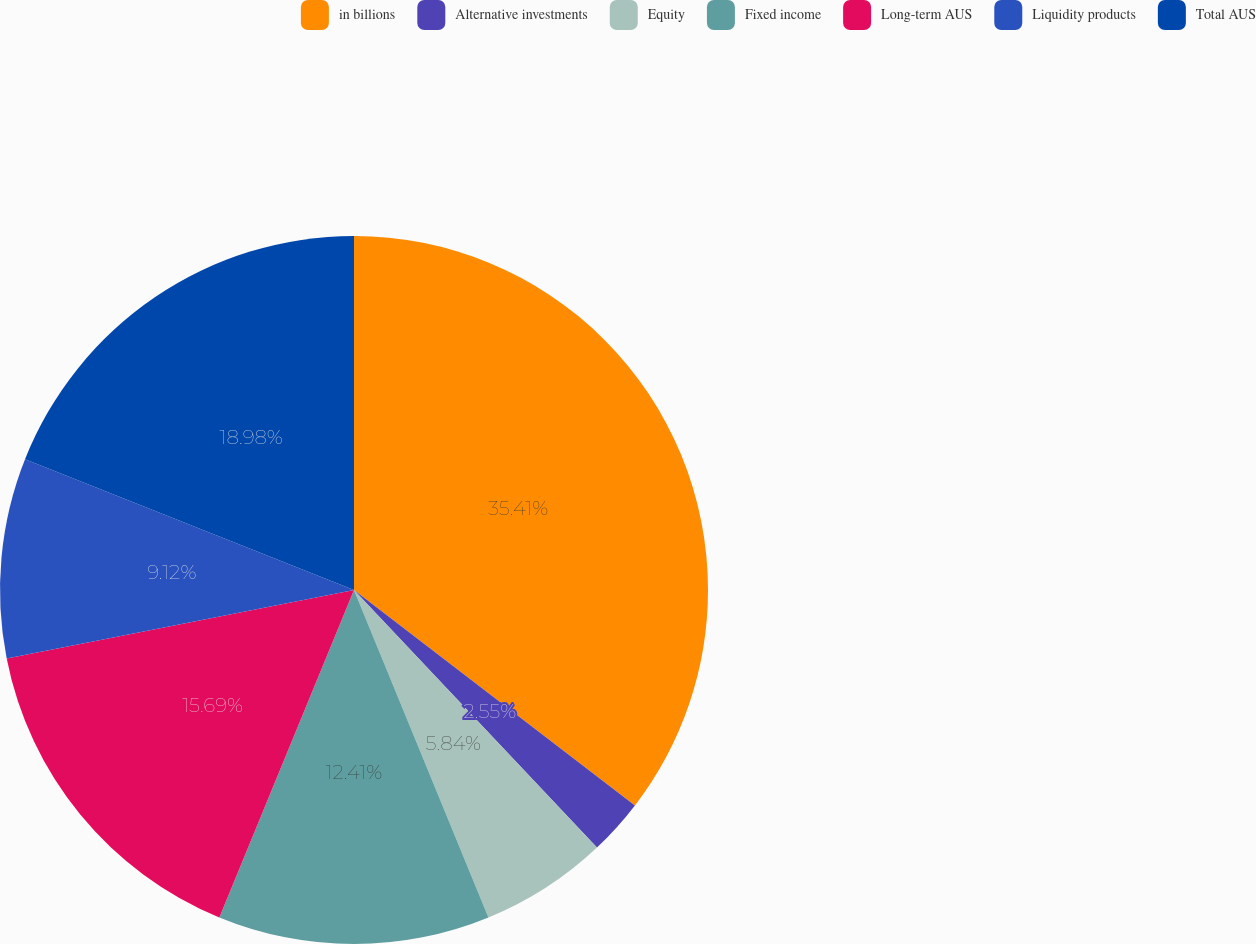<chart> <loc_0><loc_0><loc_500><loc_500><pie_chart><fcel>in billions<fcel>Alternative investments<fcel>Equity<fcel>Fixed income<fcel>Long-term AUS<fcel>Liquidity products<fcel>Total AUS<nl><fcel>35.41%<fcel>2.55%<fcel>5.84%<fcel>12.41%<fcel>15.69%<fcel>9.12%<fcel>18.98%<nl></chart> 